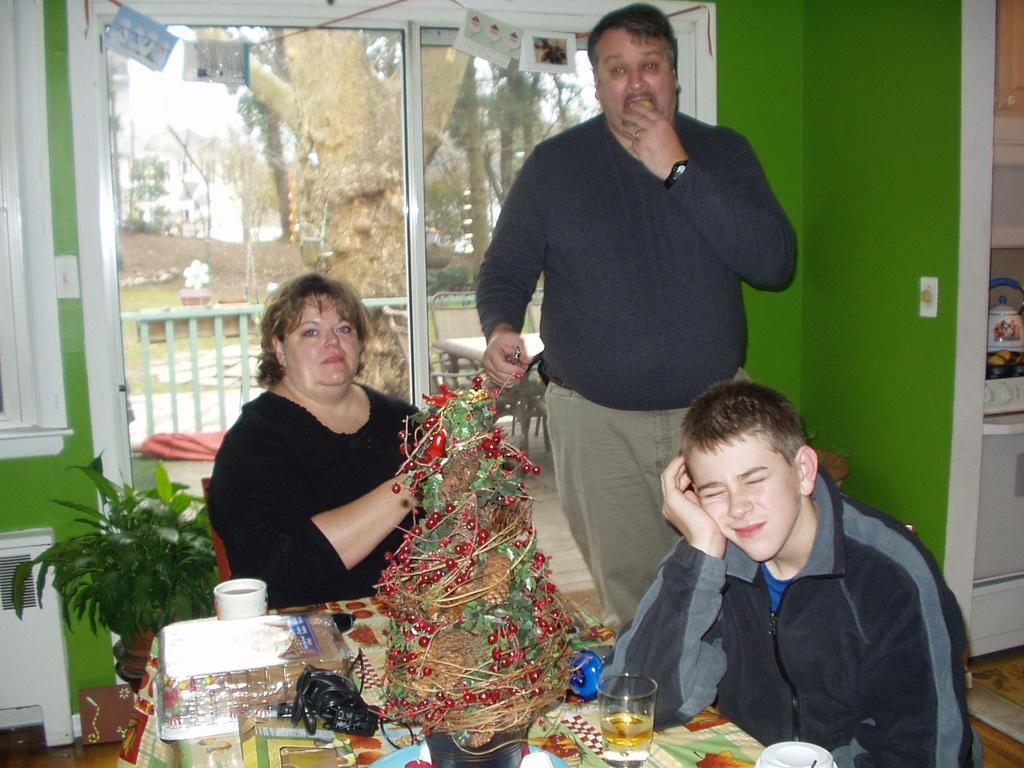In one or two sentences, can you explain what this image depicts? In the center of the image a table is there. On the table we can see glasses, cups, tree and some objects are present, beside the table a lady and a boy are sitting on a chair. In the middle of the image we can see a man is standing. At the bottom left corner a bush is there. At the top of the image we can see some trees, sky, window, cards are present. On the right side of the image we can see cupboards, containers are present. At the bottom of the image floor is there. 